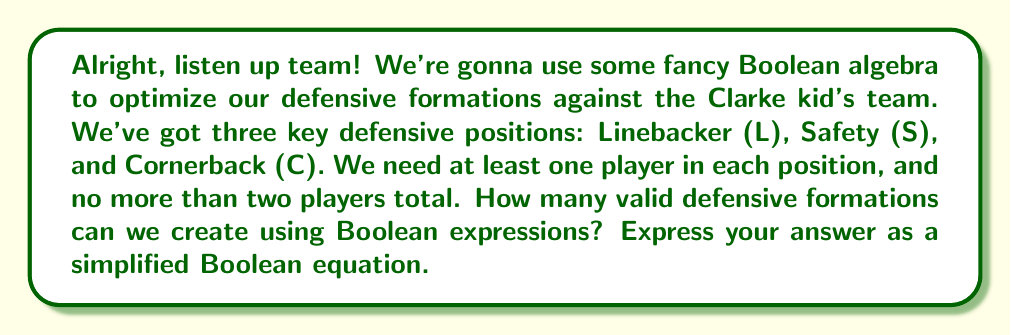Could you help me with this problem? Let's break this down step-by-step, just like we'd analyze game film:

1) First, we need to represent each position with a Boolean variable:
   L: Linebacker
   S: Safety
   C: Cornerback

2) We need at least one player in each position, so our base expression is:
   $$ L \cdot S \cdot C $$

3) Now, we can have up to two players total. This means we can add one more player to any position. We represent this with the OR operator ($+$):
   $$ L \cdot S \cdot C \cdot (L + S + C) $$

4) Let's expand this expression:
   $$ (L \cdot S \cdot C \cdot L) + (L \cdot S \cdot C \cdot S) + (L \cdot S \cdot C \cdot C) $$

5) Simplify using the idempotent law ($A \cdot A = A$):
   $$ (L \cdot S \cdot C) + (L \cdot S \cdot C) + (L \cdot S \cdot C) $$

6) Since we have three identical terms connected by OR, we can simplify this to:
   $$ L \cdot S \cdot C $$

This final expression represents all valid defensive formations that meet our criteria.
Answer: $$ L \cdot S \cdot C $$ 